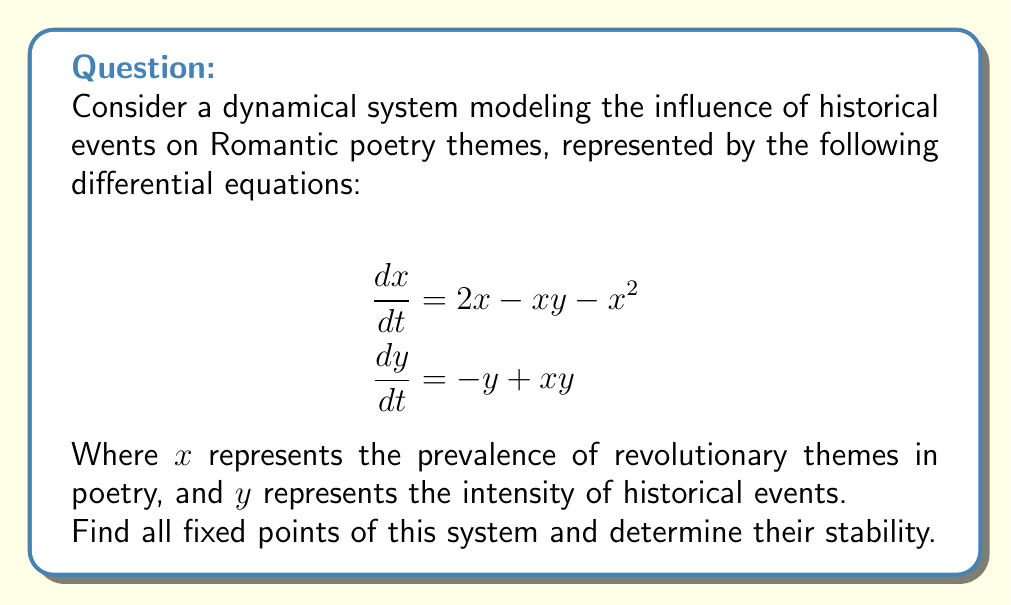Solve this math problem. 1. To find the fixed points, set both equations equal to zero:

   $$\begin{aligned}
   2x - xy - x^2 &= 0 \\
   -y + xy &= 0
   \end{aligned}$$

2. From the second equation:
   $y(x-1) = 0$, so either $y = 0$ or $x = 1$

3. Case 1: If $y = 0$, substitute into the first equation:
   $2x - x^2 = 0$
   $x(2-x) = 0$, so $x = 0$ or $x = 2$
   This gives us two fixed points: $(0,0)$ and $(2,0)$

4. Case 2: If $x = 1$, substitute into the second equation:
   $-y + y = 0$, which is always true
   Substitute $x = 1$ into the first equation:
   $2 - y - 1 = 0$, so $y = 1$
   This gives us the third fixed point: $(1,1)$

5. To determine stability, we need to find the Jacobian matrix:

   $$J = \begin{bmatrix}
   \frac{\partial}{\partial x}(2x - xy - x^2) & \frac{\partial}{\partial y}(2x - xy - x^2) \\
   \frac{\partial}{\partial x}(-y + xy) & \frac{\partial}{\partial y}(-y + xy)
   \end{bmatrix}
   = \begin{bmatrix}
   2 - y - 2x & -x \\
   y & x - 1
   \end{bmatrix}$$

6. Evaluate the Jacobian at each fixed point:

   At $(0,0)$: $J_{(0,0)} = \begin{bmatrix} 2 & 0 \\ 0 & -1 \end{bmatrix}$
   Eigenvalues: $\lambda_1 = 2, \lambda_2 = -1$
   This is an unstable saddle point.

   At $(2,0)$: $J_{(2,0)} = \begin{bmatrix} -2 & -2 \\ 0 & 1 \end{bmatrix}$
   Eigenvalues: $\lambda_1 = -2, \lambda_2 = 1$
   This is an unstable saddle point.

   At $(1,1)$: $J_{(1,1)} = \begin{bmatrix} -1 & -1 \\ 1 & 0 \end{bmatrix}$
   Eigenvalues: $\lambda_{1,2} = -\frac{1}{2} \pm \frac{\sqrt{3}}{2}i$
   This is a stable spiral point.
Answer: Fixed points: $(0,0)$, $(2,0)$, $(1,1)$. Stability: $(0,0)$ and $(2,0)$ are unstable saddle points, $(1,1)$ is a stable spiral point. 